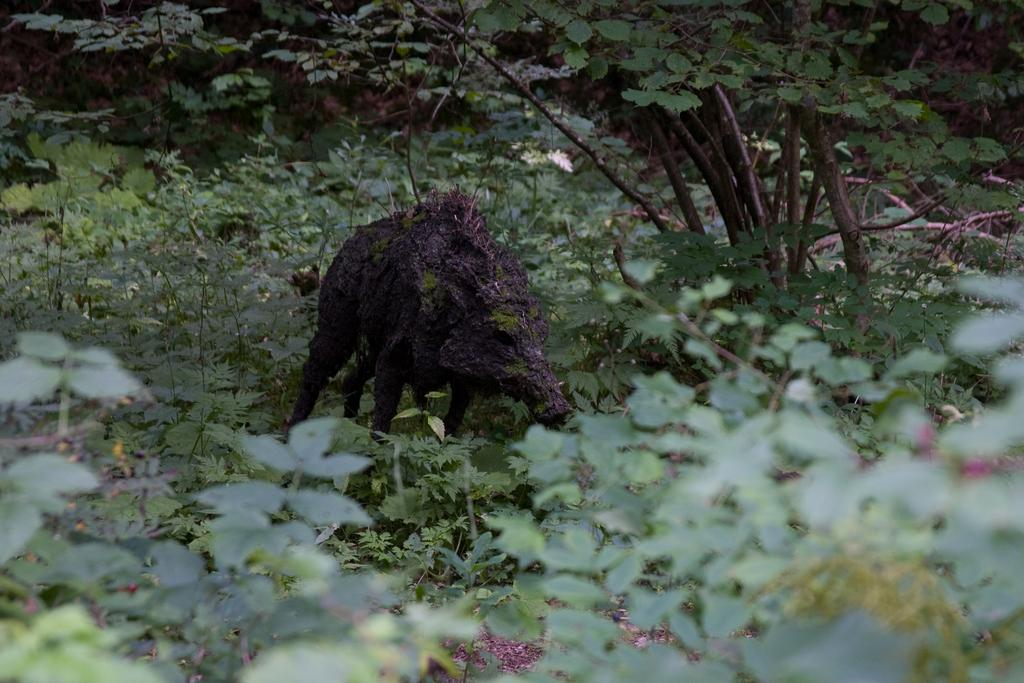What animal is present in the image? There is a pig in the image. What can be seen in the background of the image? There are plants and grass in the background of the image. What team does the pig support in the image? There is no indication of a team or any sports-related context in the image, so it cannot be determined which team the pig might support. 